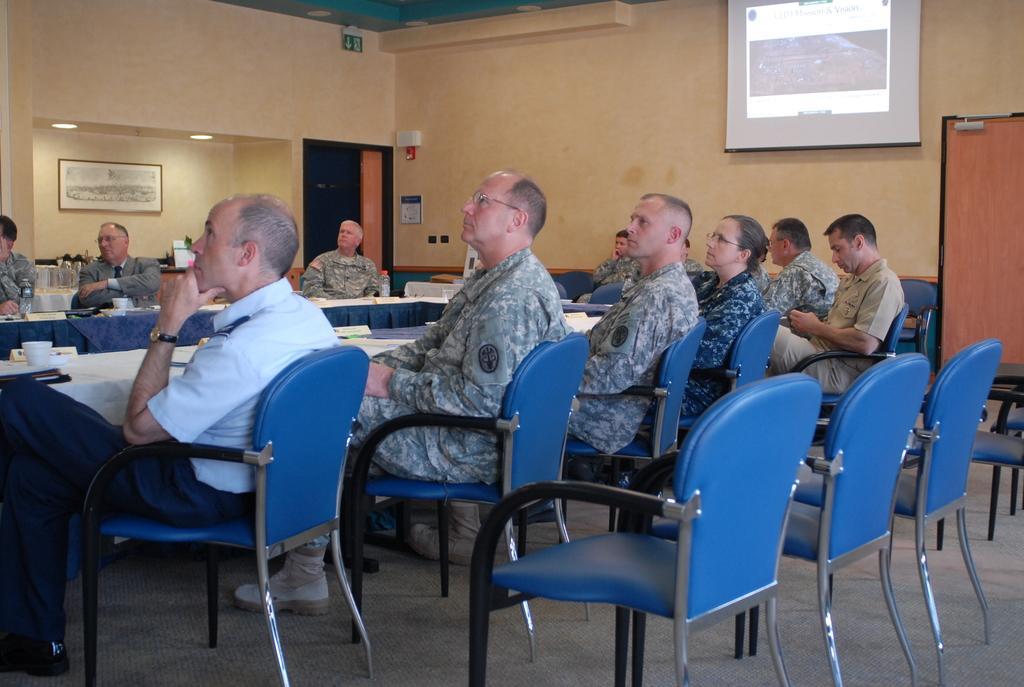Please provide a concise description of this image. In this image I can see number of people are sitting on chairs. I can also see few more chairs and a projector screen on this wall. 